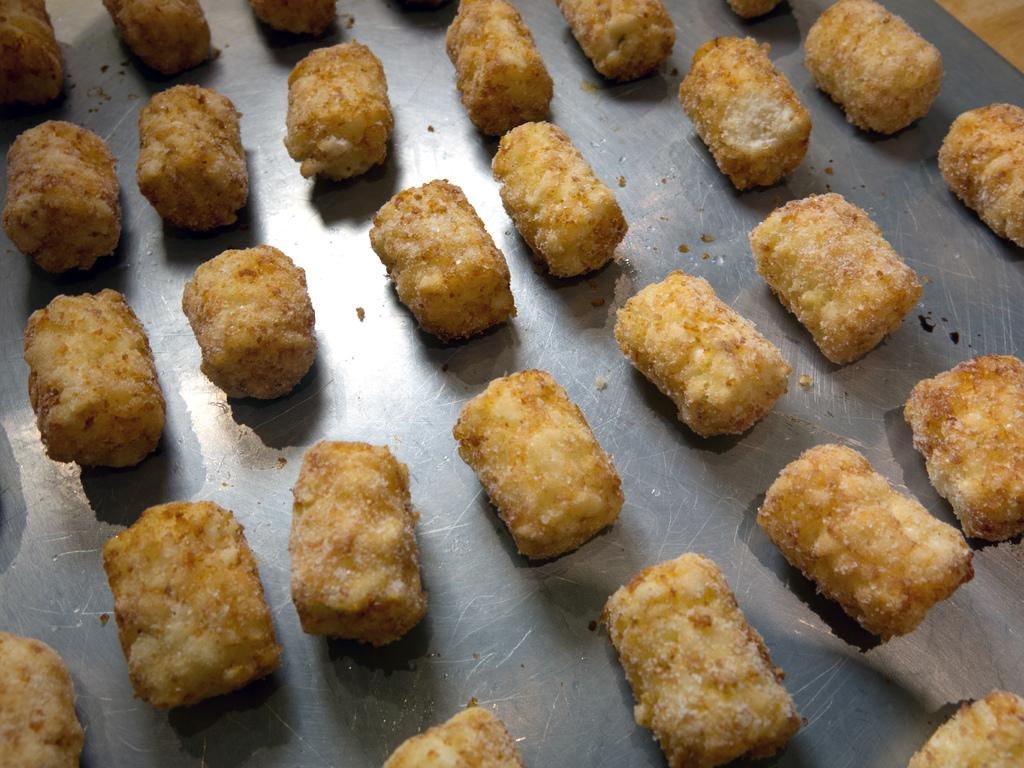What type of items can be seen in the image? There are eatables in the image. How are the eatables arranged or organized in the image? The eatables are placed in a tray. What color is the crayon used to draw on the tray in the image? There is no crayon present in the image. How does the snail move across the tray in the image? There is no snail present in the image. 